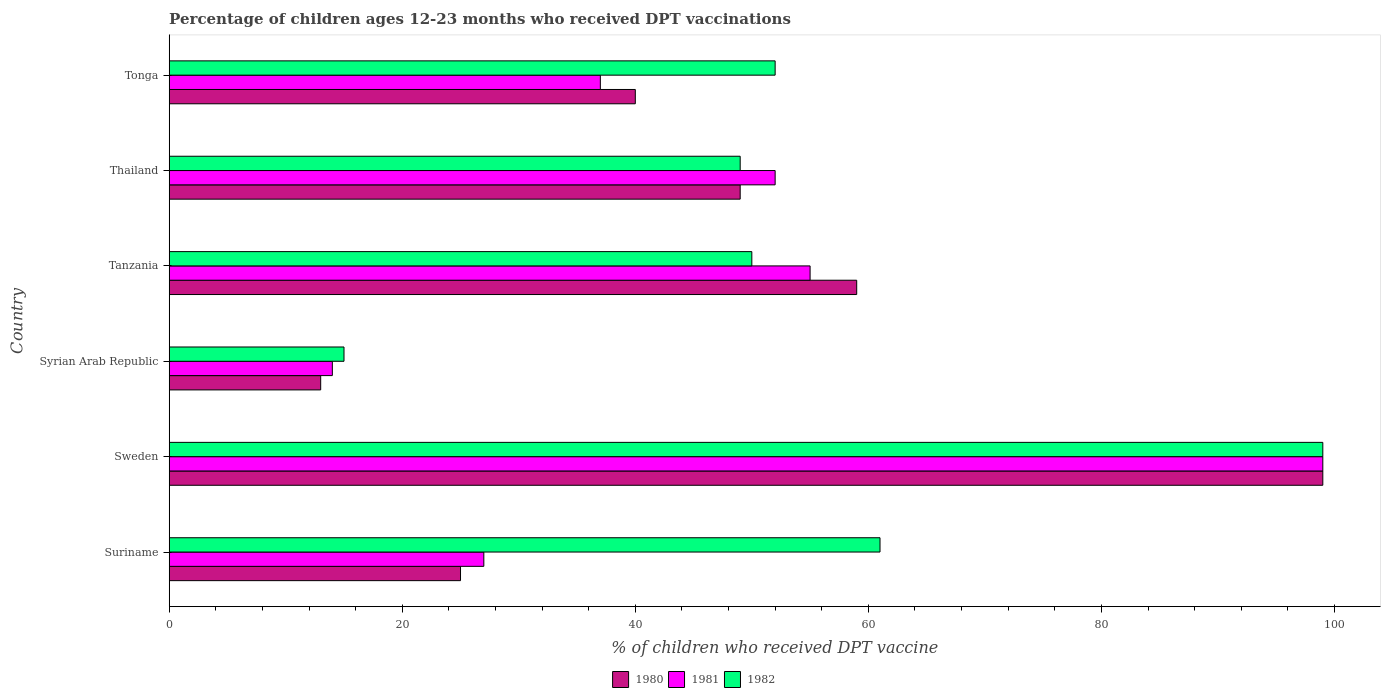How many different coloured bars are there?
Ensure brevity in your answer.  3. How many bars are there on the 2nd tick from the bottom?
Keep it short and to the point. 3. What is the label of the 6th group of bars from the top?
Give a very brief answer. Suriname. In how many cases, is the number of bars for a given country not equal to the number of legend labels?
Give a very brief answer. 0. What is the percentage of children who received DPT vaccination in 1980 in Thailand?
Make the answer very short. 49. Across all countries, what is the maximum percentage of children who received DPT vaccination in 1981?
Provide a short and direct response. 99. Across all countries, what is the minimum percentage of children who received DPT vaccination in 1982?
Your response must be concise. 15. In which country was the percentage of children who received DPT vaccination in 1980 maximum?
Make the answer very short. Sweden. In which country was the percentage of children who received DPT vaccination in 1982 minimum?
Keep it short and to the point. Syrian Arab Republic. What is the total percentage of children who received DPT vaccination in 1982 in the graph?
Provide a short and direct response. 326. What is the difference between the percentage of children who received DPT vaccination in 1982 in Syrian Arab Republic and that in Tonga?
Your response must be concise. -37. What is the average percentage of children who received DPT vaccination in 1981 per country?
Make the answer very short. 47.33. What is the difference between the percentage of children who received DPT vaccination in 1980 and percentage of children who received DPT vaccination in 1981 in Sweden?
Your answer should be very brief. 0. What is the ratio of the percentage of children who received DPT vaccination in 1980 in Sweden to that in Thailand?
Your response must be concise. 2.02. Is the percentage of children who received DPT vaccination in 1981 in Suriname less than that in Tanzania?
Ensure brevity in your answer.  Yes. What is the difference between the highest and the second highest percentage of children who received DPT vaccination in 1981?
Keep it short and to the point. 44. What does the 1st bar from the top in Suriname represents?
Give a very brief answer. 1982. How many bars are there?
Ensure brevity in your answer.  18. How many countries are there in the graph?
Offer a terse response. 6. What is the difference between two consecutive major ticks on the X-axis?
Offer a very short reply. 20. Where does the legend appear in the graph?
Make the answer very short. Bottom center. How are the legend labels stacked?
Your answer should be very brief. Horizontal. What is the title of the graph?
Make the answer very short. Percentage of children ages 12-23 months who received DPT vaccinations. What is the label or title of the X-axis?
Keep it short and to the point. % of children who received DPT vaccine. What is the label or title of the Y-axis?
Your response must be concise. Country. What is the % of children who received DPT vaccine in 1981 in Suriname?
Offer a terse response. 27. What is the % of children who received DPT vaccine in 1981 in Sweden?
Your answer should be compact. 99. What is the % of children who received DPT vaccine in 1982 in Sweden?
Give a very brief answer. 99. What is the % of children who received DPT vaccine in 1982 in Syrian Arab Republic?
Provide a succinct answer. 15. What is the % of children who received DPT vaccine of 1981 in Tanzania?
Offer a terse response. 55. What is the % of children who received DPT vaccine of 1980 in Thailand?
Your answer should be compact. 49. What is the % of children who received DPT vaccine of 1981 in Tonga?
Your answer should be very brief. 37. Across all countries, what is the maximum % of children who received DPT vaccine in 1980?
Ensure brevity in your answer.  99. Across all countries, what is the minimum % of children who received DPT vaccine of 1980?
Ensure brevity in your answer.  13. What is the total % of children who received DPT vaccine in 1980 in the graph?
Ensure brevity in your answer.  285. What is the total % of children who received DPT vaccine of 1981 in the graph?
Give a very brief answer. 284. What is the total % of children who received DPT vaccine in 1982 in the graph?
Give a very brief answer. 326. What is the difference between the % of children who received DPT vaccine in 1980 in Suriname and that in Sweden?
Offer a very short reply. -74. What is the difference between the % of children who received DPT vaccine in 1981 in Suriname and that in Sweden?
Keep it short and to the point. -72. What is the difference between the % of children who received DPT vaccine in 1982 in Suriname and that in Sweden?
Provide a short and direct response. -38. What is the difference between the % of children who received DPT vaccine of 1980 in Suriname and that in Syrian Arab Republic?
Offer a terse response. 12. What is the difference between the % of children who received DPT vaccine in 1981 in Suriname and that in Syrian Arab Republic?
Keep it short and to the point. 13. What is the difference between the % of children who received DPT vaccine in 1982 in Suriname and that in Syrian Arab Republic?
Provide a succinct answer. 46. What is the difference between the % of children who received DPT vaccine in 1980 in Suriname and that in Tanzania?
Make the answer very short. -34. What is the difference between the % of children who received DPT vaccine of 1980 in Suriname and that in Thailand?
Provide a succinct answer. -24. What is the difference between the % of children who received DPT vaccine in 1981 in Suriname and that in Thailand?
Your answer should be compact. -25. What is the difference between the % of children who received DPT vaccine of 1980 in Suriname and that in Tonga?
Make the answer very short. -15. What is the difference between the % of children who received DPT vaccine in 1981 in Suriname and that in Tonga?
Offer a terse response. -10. What is the difference between the % of children who received DPT vaccine in 1980 in Sweden and that in Syrian Arab Republic?
Your answer should be very brief. 86. What is the difference between the % of children who received DPT vaccine of 1982 in Sweden and that in Tanzania?
Keep it short and to the point. 49. What is the difference between the % of children who received DPT vaccine of 1982 in Sweden and that in Tonga?
Offer a very short reply. 47. What is the difference between the % of children who received DPT vaccine of 1980 in Syrian Arab Republic and that in Tanzania?
Ensure brevity in your answer.  -46. What is the difference between the % of children who received DPT vaccine in 1981 in Syrian Arab Republic and that in Tanzania?
Your answer should be compact. -41. What is the difference between the % of children who received DPT vaccine of 1982 in Syrian Arab Republic and that in Tanzania?
Make the answer very short. -35. What is the difference between the % of children who received DPT vaccine in 1980 in Syrian Arab Republic and that in Thailand?
Your answer should be very brief. -36. What is the difference between the % of children who received DPT vaccine in 1981 in Syrian Arab Republic and that in Thailand?
Your answer should be very brief. -38. What is the difference between the % of children who received DPT vaccine in 1982 in Syrian Arab Republic and that in Thailand?
Make the answer very short. -34. What is the difference between the % of children who received DPT vaccine in 1980 in Syrian Arab Republic and that in Tonga?
Make the answer very short. -27. What is the difference between the % of children who received DPT vaccine in 1981 in Syrian Arab Republic and that in Tonga?
Make the answer very short. -23. What is the difference between the % of children who received DPT vaccine in 1982 in Syrian Arab Republic and that in Tonga?
Give a very brief answer. -37. What is the difference between the % of children who received DPT vaccine of 1981 in Tanzania and that in Thailand?
Your answer should be compact. 3. What is the difference between the % of children who received DPT vaccine of 1982 in Tanzania and that in Thailand?
Offer a terse response. 1. What is the difference between the % of children who received DPT vaccine of 1980 in Thailand and that in Tonga?
Provide a short and direct response. 9. What is the difference between the % of children who received DPT vaccine in 1980 in Suriname and the % of children who received DPT vaccine in 1981 in Sweden?
Offer a very short reply. -74. What is the difference between the % of children who received DPT vaccine of 1980 in Suriname and the % of children who received DPT vaccine of 1982 in Sweden?
Keep it short and to the point. -74. What is the difference between the % of children who received DPT vaccine in 1981 in Suriname and the % of children who received DPT vaccine in 1982 in Sweden?
Your answer should be compact. -72. What is the difference between the % of children who received DPT vaccine in 1981 in Suriname and the % of children who received DPT vaccine in 1982 in Syrian Arab Republic?
Give a very brief answer. 12. What is the difference between the % of children who received DPT vaccine of 1980 in Suriname and the % of children who received DPT vaccine of 1982 in Tanzania?
Offer a very short reply. -25. What is the difference between the % of children who received DPT vaccine in 1980 in Suriname and the % of children who received DPT vaccine in 1982 in Thailand?
Provide a succinct answer. -24. What is the difference between the % of children who received DPT vaccine of 1981 in Suriname and the % of children who received DPT vaccine of 1982 in Tonga?
Ensure brevity in your answer.  -25. What is the difference between the % of children who received DPT vaccine in 1980 in Sweden and the % of children who received DPT vaccine in 1981 in Syrian Arab Republic?
Offer a terse response. 85. What is the difference between the % of children who received DPT vaccine in 1980 in Sweden and the % of children who received DPT vaccine in 1982 in Syrian Arab Republic?
Your answer should be very brief. 84. What is the difference between the % of children who received DPT vaccine in 1980 in Sweden and the % of children who received DPT vaccine in 1981 in Tanzania?
Your answer should be very brief. 44. What is the difference between the % of children who received DPT vaccine of 1980 in Sweden and the % of children who received DPT vaccine of 1982 in Tanzania?
Your answer should be very brief. 49. What is the difference between the % of children who received DPT vaccine of 1981 in Sweden and the % of children who received DPT vaccine of 1982 in Tanzania?
Keep it short and to the point. 49. What is the difference between the % of children who received DPT vaccine of 1980 in Sweden and the % of children who received DPT vaccine of 1981 in Thailand?
Ensure brevity in your answer.  47. What is the difference between the % of children who received DPT vaccine in 1980 in Sweden and the % of children who received DPT vaccine in 1981 in Tonga?
Your answer should be very brief. 62. What is the difference between the % of children who received DPT vaccine of 1980 in Sweden and the % of children who received DPT vaccine of 1982 in Tonga?
Keep it short and to the point. 47. What is the difference between the % of children who received DPT vaccine of 1981 in Sweden and the % of children who received DPT vaccine of 1982 in Tonga?
Your answer should be compact. 47. What is the difference between the % of children who received DPT vaccine of 1980 in Syrian Arab Republic and the % of children who received DPT vaccine of 1981 in Tanzania?
Keep it short and to the point. -42. What is the difference between the % of children who received DPT vaccine in 1980 in Syrian Arab Republic and the % of children who received DPT vaccine in 1982 in Tanzania?
Ensure brevity in your answer.  -37. What is the difference between the % of children who received DPT vaccine of 1981 in Syrian Arab Republic and the % of children who received DPT vaccine of 1982 in Tanzania?
Provide a succinct answer. -36. What is the difference between the % of children who received DPT vaccine of 1980 in Syrian Arab Republic and the % of children who received DPT vaccine of 1981 in Thailand?
Your answer should be compact. -39. What is the difference between the % of children who received DPT vaccine in 1980 in Syrian Arab Republic and the % of children who received DPT vaccine in 1982 in Thailand?
Your response must be concise. -36. What is the difference between the % of children who received DPT vaccine of 1981 in Syrian Arab Republic and the % of children who received DPT vaccine of 1982 in Thailand?
Make the answer very short. -35. What is the difference between the % of children who received DPT vaccine in 1980 in Syrian Arab Republic and the % of children who received DPT vaccine in 1982 in Tonga?
Give a very brief answer. -39. What is the difference between the % of children who received DPT vaccine in 1981 in Syrian Arab Republic and the % of children who received DPT vaccine in 1982 in Tonga?
Make the answer very short. -38. What is the difference between the % of children who received DPT vaccine of 1981 in Tanzania and the % of children who received DPT vaccine of 1982 in Thailand?
Make the answer very short. 6. What is the difference between the % of children who received DPT vaccine in 1980 in Thailand and the % of children who received DPT vaccine in 1981 in Tonga?
Offer a very short reply. 12. What is the difference between the % of children who received DPT vaccine in 1980 in Thailand and the % of children who received DPT vaccine in 1982 in Tonga?
Provide a short and direct response. -3. What is the average % of children who received DPT vaccine of 1980 per country?
Make the answer very short. 47.5. What is the average % of children who received DPT vaccine of 1981 per country?
Give a very brief answer. 47.33. What is the average % of children who received DPT vaccine in 1982 per country?
Offer a terse response. 54.33. What is the difference between the % of children who received DPT vaccine of 1980 and % of children who received DPT vaccine of 1982 in Suriname?
Offer a very short reply. -36. What is the difference between the % of children who received DPT vaccine of 1981 and % of children who received DPT vaccine of 1982 in Suriname?
Offer a very short reply. -34. What is the difference between the % of children who received DPT vaccine in 1980 and % of children who received DPT vaccine in 1981 in Sweden?
Provide a succinct answer. 0. What is the difference between the % of children who received DPT vaccine of 1981 and % of children who received DPT vaccine of 1982 in Sweden?
Offer a very short reply. 0. What is the difference between the % of children who received DPT vaccine in 1980 and % of children who received DPT vaccine in 1981 in Syrian Arab Republic?
Give a very brief answer. -1. What is the difference between the % of children who received DPT vaccine of 1981 and % of children who received DPT vaccine of 1982 in Syrian Arab Republic?
Provide a short and direct response. -1. What is the difference between the % of children who received DPT vaccine of 1980 and % of children who received DPT vaccine of 1981 in Thailand?
Keep it short and to the point. -3. What is the difference between the % of children who received DPT vaccine in 1980 and % of children who received DPT vaccine in 1982 in Tonga?
Provide a succinct answer. -12. What is the difference between the % of children who received DPT vaccine of 1981 and % of children who received DPT vaccine of 1982 in Tonga?
Keep it short and to the point. -15. What is the ratio of the % of children who received DPT vaccine in 1980 in Suriname to that in Sweden?
Keep it short and to the point. 0.25. What is the ratio of the % of children who received DPT vaccine in 1981 in Suriname to that in Sweden?
Your answer should be very brief. 0.27. What is the ratio of the % of children who received DPT vaccine in 1982 in Suriname to that in Sweden?
Your answer should be compact. 0.62. What is the ratio of the % of children who received DPT vaccine of 1980 in Suriname to that in Syrian Arab Republic?
Make the answer very short. 1.92. What is the ratio of the % of children who received DPT vaccine of 1981 in Suriname to that in Syrian Arab Republic?
Make the answer very short. 1.93. What is the ratio of the % of children who received DPT vaccine of 1982 in Suriname to that in Syrian Arab Republic?
Provide a succinct answer. 4.07. What is the ratio of the % of children who received DPT vaccine of 1980 in Suriname to that in Tanzania?
Make the answer very short. 0.42. What is the ratio of the % of children who received DPT vaccine in 1981 in Suriname to that in Tanzania?
Ensure brevity in your answer.  0.49. What is the ratio of the % of children who received DPT vaccine in 1982 in Suriname to that in Tanzania?
Your answer should be compact. 1.22. What is the ratio of the % of children who received DPT vaccine in 1980 in Suriname to that in Thailand?
Your answer should be compact. 0.51. What is the ratio of the % of children who received DPT vaccine of 1981 in Suriname to that in Thailand?
Give a very brief answer. 0.52. What is the ratio of the % of children who received DPT vaccine in 1982 in Suriname to that in Thailand?
Your answer should be very brief. 1.24. What is the ratio of the % of children who received DPT vaccine in 1981 in Suriname to that in Tonga?
Make the answer very short. 0.73. What is the ratio of the % of children who received DPT vaccine of 1982 in Suriname to that in Tonga?
Keep it short and to the point. 1.17. What is the ratio of the % of children who received DPT vaccine of 1980 in Sweden to that in Syrian Arab Republic?
Your answer should be very brief. 7.62. What is the ratio of the % of children who received DPT vaccine of 1981 in Sweden to that in Syrian Arab Republic?
Make the answer very short. 7.07. What is the ratio of the % of children who received DPT vaccine in 1980 in Sweden to that in Tanzania?
Your answer should be compact. 1.68. What is the ratio of the % of children who received DPT vaccine of 1981 in Sweden to that in Tanzania?
Your response must be concise. 1.8. What is the ratio of the % of children who received DPT vaccine of 1982 in Sweden to that in Tanzania?
Offer a very short reply. 1.98. What is the ratio of the % of children who received DPT vaccine of 1980 in Sweden to that in Thailand?
Provide a succinct answer. 2.02. What is the ratio of the % of children who received DPT vaccine of 1981 in Sweden to that in Thailand?
Your answer should be very brief. 1.9. What is the ratio of the % of children who received DPT vaccine of 1982 in Sweden to that in Thailand?
Provide a succinct answer. 2.02. What is the ratio of the % of children who received DPT vaccine in 1980 in Sweden to that in Tonga?
Give a very brief answer. 2.48. What is the ratio of the % of children who received DPT vaccine in 1981 in Sweden to that in Tonga?
Your answer should be very brief. 2.68. What is the ratio of the % of children who received DPT vaccine in 1982 in Sweden to that in Tonga?
Give a very brief answer. 1.9. What is the ratio of the % of children who received DPT vaccine of 1980 in Syrian Arab Republic to that in Tanzania?
Offer a very short reply. 0.22. What is the ratio of the % of children who received DPT vaccine in 1981 in Syrian Arab Republic to that in Tanzania?
Keep it short and to the point. 0.25. What is the ratio of the % of children who received DPT vaccine of 1982 in Syrian Arab Republic to that in Tanzania?
Your response must be concise. 0.3. What is the ratio of the % of children who received DPT vaccine in 1980 in Syrian Arab Republic to that in Thailand?
Your response must be concise. 0.27. What is the ratio of the % of children who received DPT vaccine of 1981 in Syrian Arab Republic to that in Thailand?
Give a very brief answer. 0.27. What is the ratio of the % of children who received DPT vaccine of 1982 in Syrian Arab Republic to that in Thailand?
Provide a succinct answer. 0.31. What is the ratio of the % of children who received DPT vaccine of 1980 in Syrian Arab Republic to that in Tonga?
Give a very brief answer. 0.33. What is the ratio of the % of children who received DPT vaccine of 1981 in Syrian Arab Republic to that in Tonga?
Make the answer very short. 0.38. What is the ratio of the % of children who received DPT vaccine in 1982 in Syrian Arab Republic to that in Tonga?
Offer a very short reply. 0.29. What is the ratio of the % of children who received DPT vaccine in 1980 in Tanzania to that in Thailand?
Offer a terse response. 1.2. What is the ratio of the % of children who received DPT vaccine of 1981 in Tanzania to that in Thailand?
Provide a short and direct response. 1.06. What is the ratio of the % of children who received DPT vaccine in 1982 in Tanzania to that in Thailand?
Make the answer very short. 1.02. What is the ratio of the % of children who received DPT vaccine in 1980 in Tanzania to that in Tonga?
Your response must be concise. 1.48. What is the ratio of the % of children who received DPT vaccine of 1981 in Tanzania to that in Tonga?
Your answer should be compact. 1.49. What is the ratio of the % of children who received DPT vaccine in 1982 in Tanzania to that in Tonga?
Make the answer very short. 0.96. What is the ratio of the % of children who received DPT vaccine of 1980 in Thailand to that in Tonga?
Ensure brevity in your answer.  1.23. What is the ratio of the % of children who received DPT vaccine in 1981 in Thailand to that in Tonga?
Ensure brevity in your answer.  1.41. What is the ratio of the % of children who received DPT vaccine in 1982 in Thailand to that in Tonga?
Your answer should be very brief. 0.94. What is the difference between the highest and the second highest % of children who received DPT vaccine of 1980?
Keep it short and to the point. 40. What is the difference between the highest and the second highest % of children who received DPT vaccine of 1982?
Provide a succinct answer. 38. What is the difference between the highest and the lowest % of children who received DPT vaccine in 1980?
Your answer should be very brief. 86. What is the difference between the highest and the lowest % of children who received DPT vaccine of 1981?
Your response must be concise. 85. 